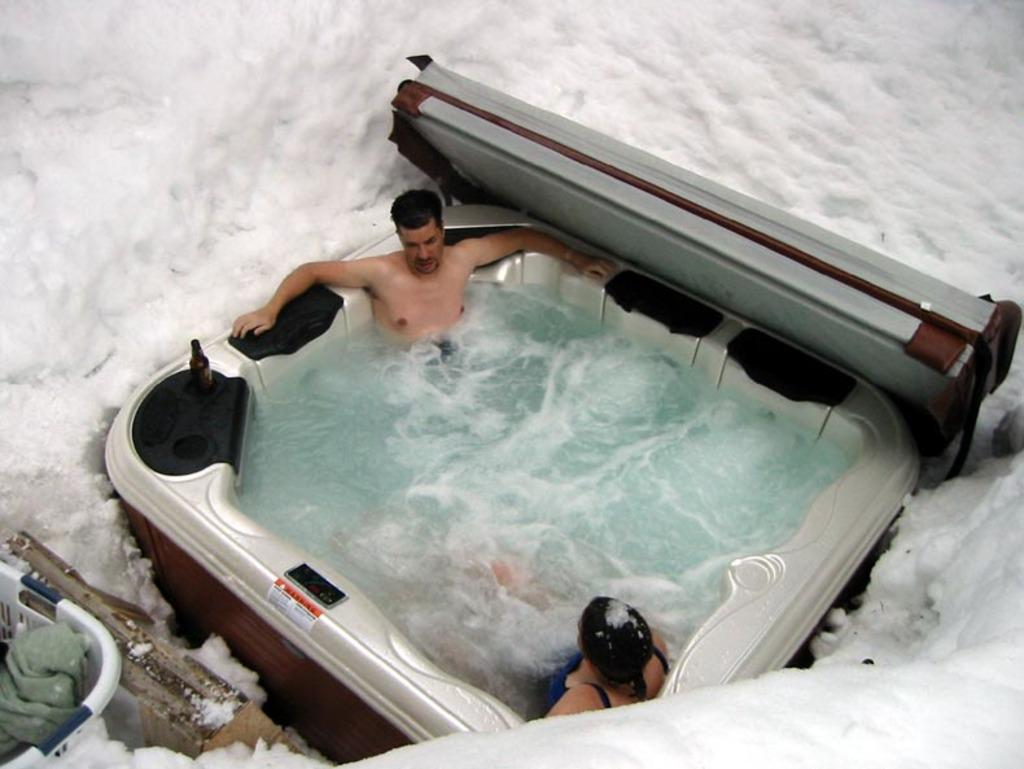What are the people doing in the image? The people are in an object filled with water. What can be seen in the bottom left corner of the image? There are objects in the bottom left corner of the image. What is the condition of the ground in the image? The ground is covered with snow. What type of pie is being served on the shelf in the image? There is no shelf or pie present in the image. 